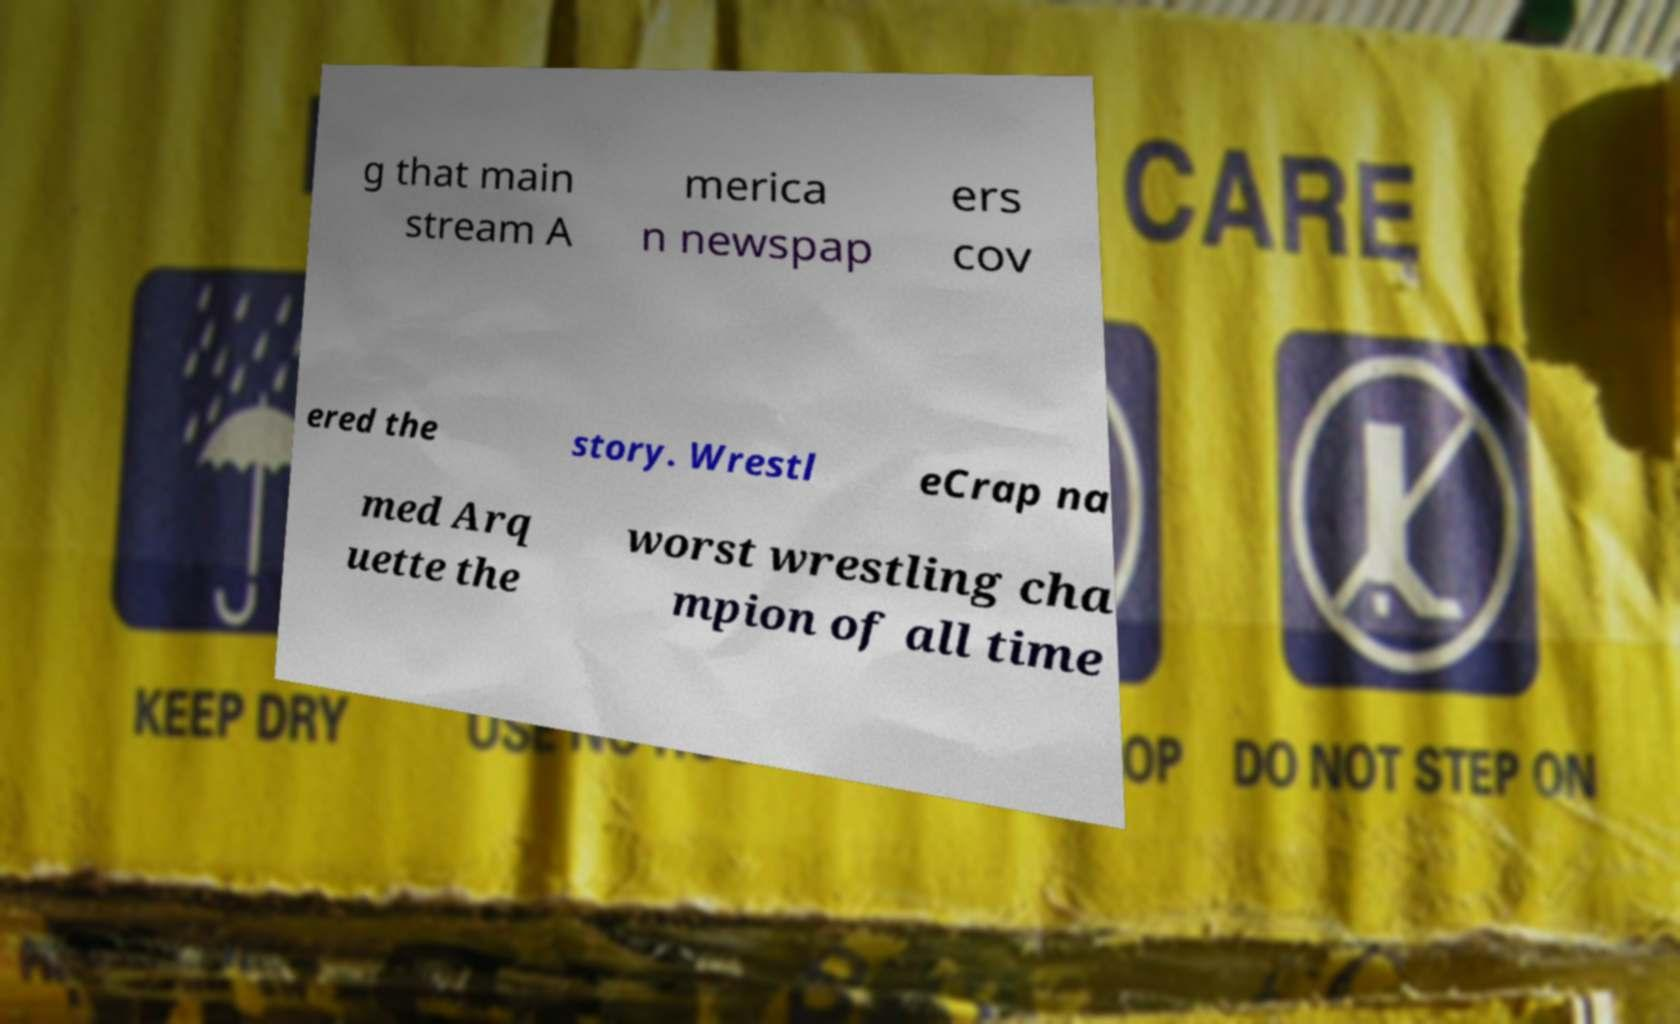Could you extract and type out the text from this image? g that main stream A merica n newspap ers cov ered the story. Wrestl eCrap na med Arq uette the worst wrestling cha mpion of all time 